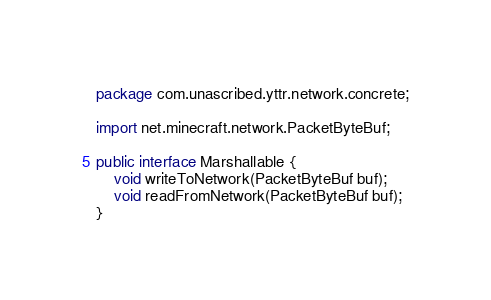<code> <loc_0><loc_0><loc_500><loc_500><_Java_>package com.unascribed.yttr.network.concrete;

import net.minecraft.network.PacketByteBuf;

public interface Marshallable {
	void writeToNetwork(PacketByteBuf buf);
	void readFromNetwork(PacketByteBuf buf);
}
</code> 